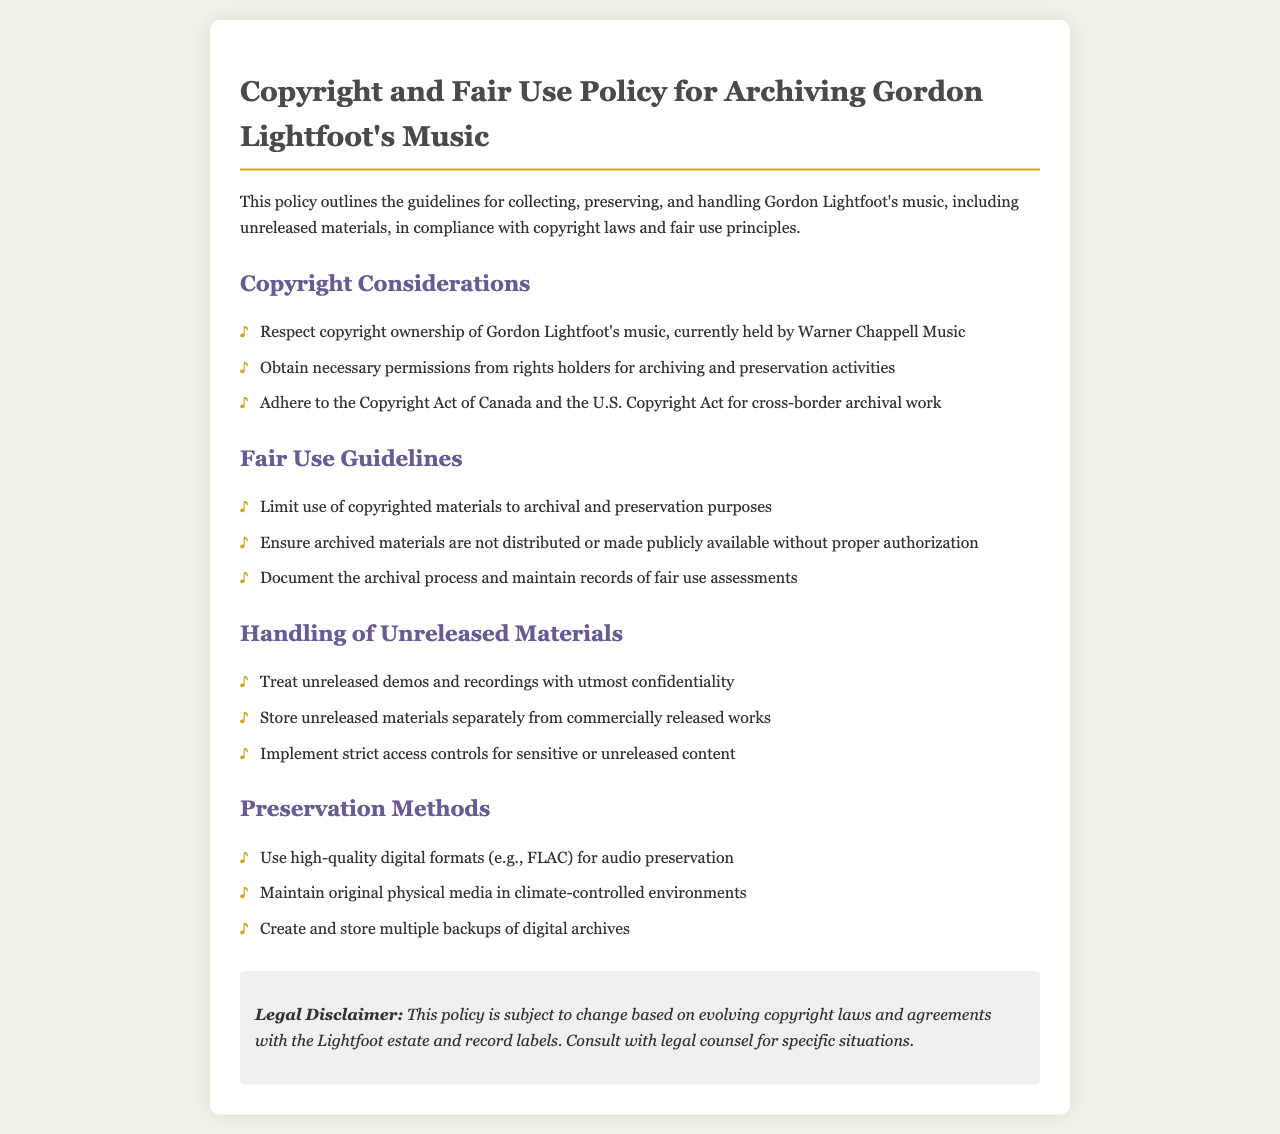what is the copyright owner of Gordon Lightfoot's music? The document states that the copyright ownership is currently held by Warner Chappell Music.
Answer: Warner Chappell Music what does the policy require for archiving activities? The policy requires obtaining necessary permissions from rights holders for archiving and preservation activities.
Answer: Necessary permissions what should be used for audio preservation? The document specifies using high-quality digital formats for audio preservation.
Answer: High-quality digital formats how should unreleased materials be stored? The policy instructs that unreleased materials should be stored separately from commercially released works.
Answer: Stored separately what does the policy advise regarding access to sensitive content? It advises implementing strict access controls for sensitive or unreleased content.
Answer: Strict access controls which copyright acts are mentioned in the policy? The document refers to the Copyright Act of Canada and the U.S. Copyright Act for cross-border archival work.
Answer: Copyright Act of Canada and U.S. Copyright Act what type of records should be maintained during the archival process? The policy states that records of fair use assessments should be maintained.
Answer: Fair use assessments how should original physical media be maintained? The document says original physical media should be maintained in climate-controlled environments.
Answer: Climate-controlled environments what is the implication of the legal disclaimer in the document? The legal disclaimer indicates that the policy is subject to change based on evolving copyright laws.
Answer: Subject to change 